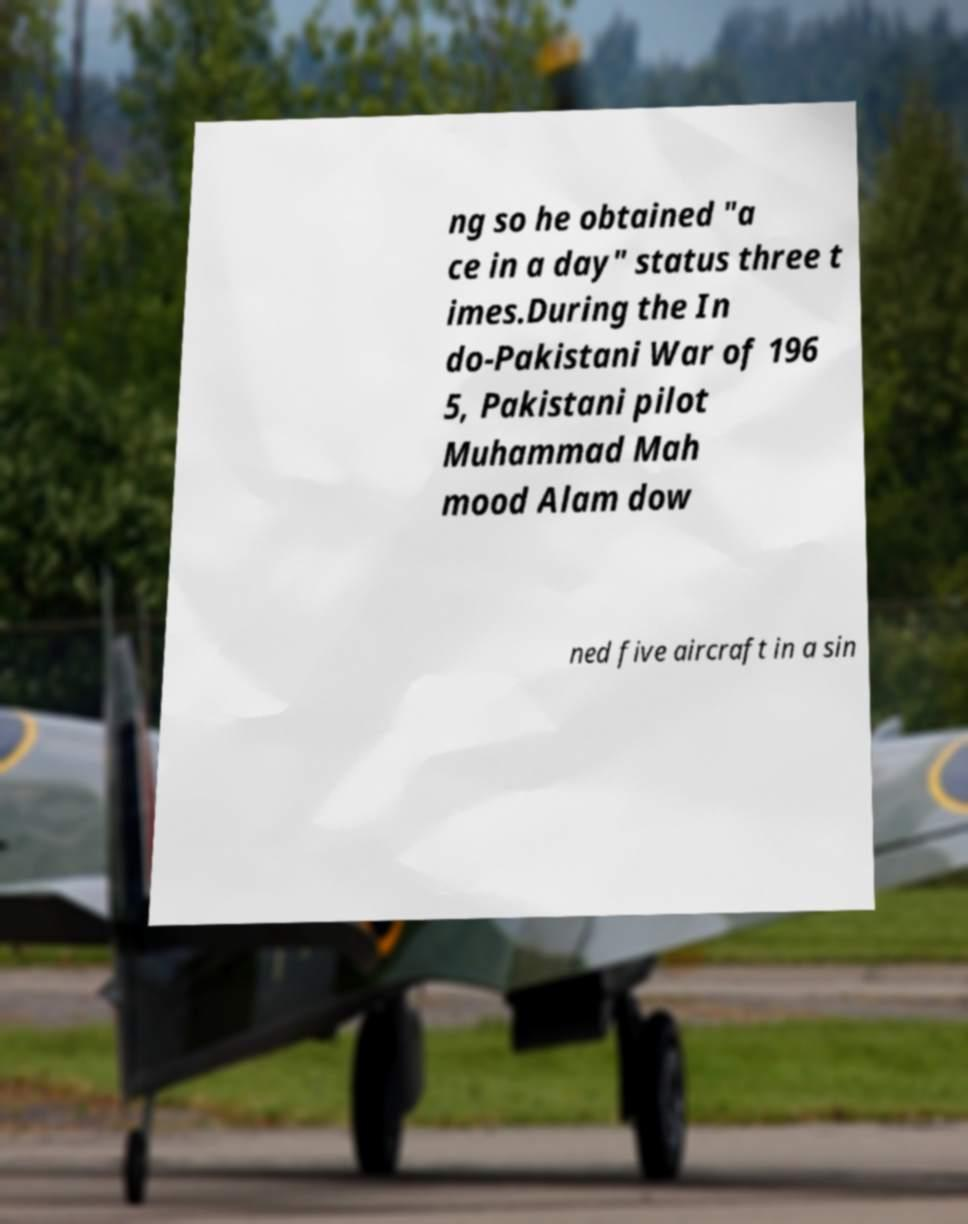What messages or text are displayed in this image? I need them in a readable, typed format. ng so he obtained "a ce in a day" status three t imes.During the In do-Pakistani War of 196 5, Pakistani pilot Muhammad Mah mood Alam dow ned five aircraft in a sin 